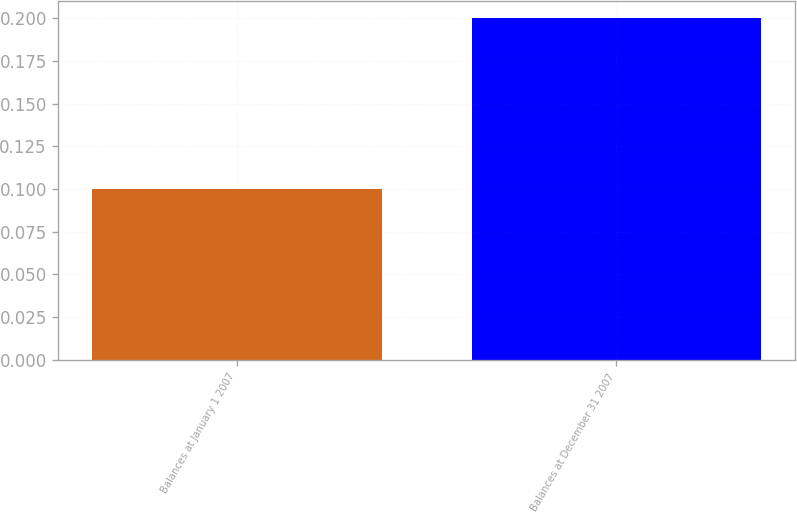<chart> <loc_0><loc_0><loc_500><loc_500><bar_chart><fcel>Balances at January 1 2007<fcel>Balances at December 31 2007<nl><fcel>0.1<fcel>0.2<nl></chart> 